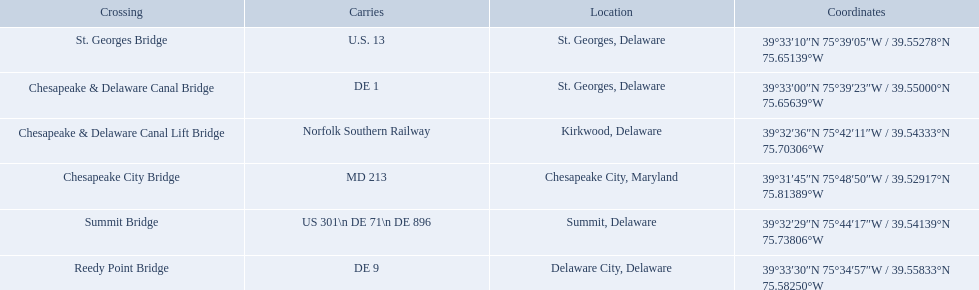What are the carries of the crossing located in summit, delaware? US 301\n DE 71\n DE 896. Based on the answer in the previous question, what is the name of the crossing? Summit Bridge. 